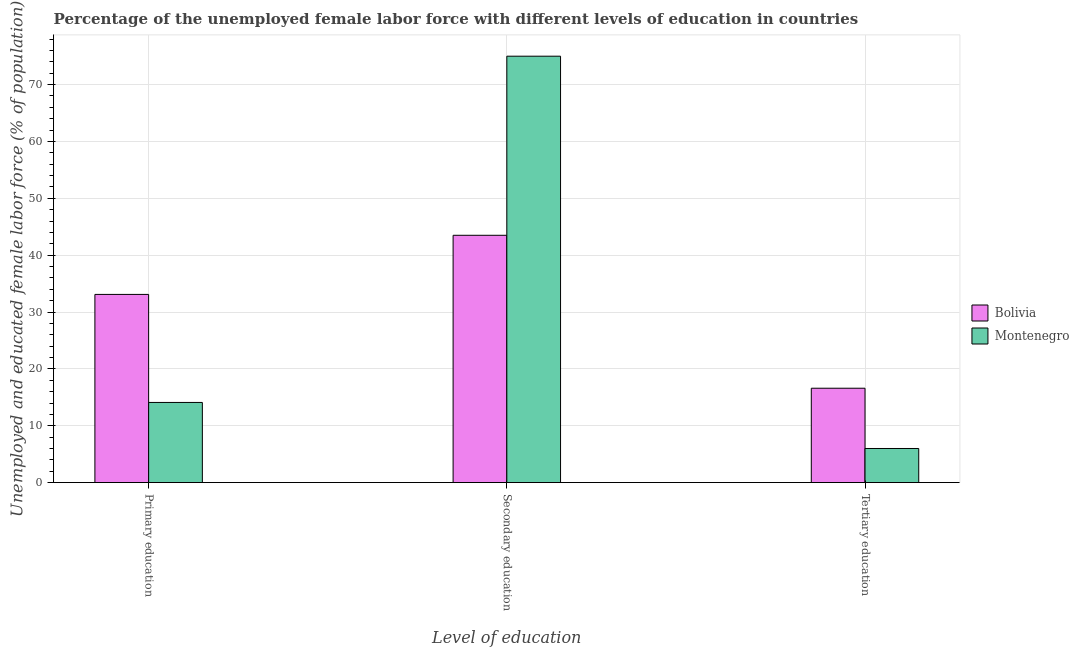How many bars are there on the 1st tick from the right?
Keep it short and to the point. 2. What is the label of the 1st group of bars from the left?
Provide a succinct answer. Primary education. What is the percentage of female labor force who received primary education in Bolivia?
Your response must be concise. 33.1. Across all countries, what is the maximum percentage of female labor force who received secondary education?
Offer a terse response. 75. Across all countries, what is the minimum percentage of female labor force who received secondary education?
Your answer should be very brief. 43.5. In which country was the percentage of female labor force who received primary education minimum?
Offer a very short reply. Montenegro. What is the total percentage of female labor force who received tertiary education in the graph?
Your answer should be compact. 22.6. What is the difference between the percentage of female labor force who received secondary education in Bolivia and that in Montenegro?
Ensure brevity in your answer.  -31.5. What is the difference between the percentage of female labor force who received secondary education in Bolivia and the percentage of female labor force who received primary education in Montenegro?
Offer a terse response. 29.4. What is the average percentage of female labor force who received primary education per country?
Provide a succinct answer. 23.6. What is the difference between the percentage of female labor force who received primary education and percentage of female labor force who received tertiary education in Montenegro?
Give a very brief answer. 8.1. What is the ratio of the percentage of female labor force who received primary education in Bolivia to that in Montenegro?
Give a very brief answer. 2.35. Is the percentage of female labor force who received primary education in Bolivia less than that in Montenegro?
Provide a short and direct response. No. Is the difference between the percentage of female labor force who received tertiary education in Bolivia and Montenegro greater than the difference between the percentage of female labor force who received secondary education in Bolivia and Montenegro?
Make the answer very short. Yes. What is the difference between the highest and the second highest percentage of female labor force who received secondary education?
Keep it short and to the point. 31.5. What is the difference between the highest and the lowest percentage of female labor force who received primary education?
Ensure brevity in your answer.  19. Is the sum of the percentage of female labor force who received tertiary education in Montenegro and Bolivia greater than the maximum percentage of female labor force who received primary education across all countries?
Your response must be concise. No. What does the 1st bar from the right in Tertiary education represents?
Make the answer very short. Montenegro. Is it the case that in every country, the sum of the percentage of female labor force who received primary education and percentage of female labor force who received secondary education is greater than the percentage of female labor force who received tertiary education?
Offer a very short reply. Yes. How many bars are there?
Ensure brevity in your answer.  6. Are all the bars in the graph horizontal?
Your response must be concise. No. How many countries are there in the graph?
Your answer should be very brief. 2. What is the difference between two consecutive major ticks on the Y-axis?
Offer a very short reply. 10. Does the graph contain any zero values?
Your answer should be very brief. No. Does the graph contain grids?
Offer a terse response. Yes. How many legend labels are there?
Your response must be concise. 2. How are the legend labels stacked?
Make the answer very short. Vertical. What is the title of the graph?
Provide a succinct answer. Percentage of the unemployed female labor force with different levels of education in countries. Does "Bulgaria" appear as one of the legend labels in the graph?
Your answer should be compact. No. What is the label or title of the X-axis?
Keep it short and to the point. Level of education. What is the label or title of the Y-axis?
Keep it short and to the point. Unemployed and educated female labor force (% of population). What is the Unemployed and educated female labor force (% of population) of Bolivia in Primary education?
Give a very brief answer. 33.1. What is the Unemployed and educated female labor force (% of population) of Montenegro in Primary education?
Your answer should be compact. 14.1. What is the Unemployed and educated female labor force (% of population) of Bolivia in Secondary education?
Provide a short and direct response. 43.5. What is the Unemployed and educated female labor force (% of population) in Montenegro in Secondary education?
Provide a short and direct response. 75. What is the Unemployed and educated female labor force (% of population) in Bolivia in Tertiary education?
Your answer should be very brief. 16.6. Across all Level of education, what is the maximum Unemployed and educated female labor force (% of population) in Bolivia?
Your answer should be very brief. 43.5. Across all Level of education, what is the maximum Unemployed and educated female labor force (% of population) in Montenegro?
Keep it short and to the point. 75. Across all Level of education, what is the minimum Unemployed and educated female labor force (% of population) in Bolivia?
Provide a succinct answer. 16.6. Across all Level of education, what is the minimum Unemployed and educated female labor force (% of population) of Montenegro?
Offer a terse response. 6. What is the total Unemployed and educated female labor force (% of population) of Bolivia in the graph?
Your answer should be very brief. 93.2. What is the total Unemployed and educated female labor force (% of population) of Montenegro in the graph?
Make the answer very short. 95.1. What is the difference between the Unemployed and educated female labor force (% of population) of Montenegro in Primary education and that in Secondary education?
Give a very brief answer. -60.9. What is the difference between the Unemployed and educated female labor force (% of population) of Bolivia in Primary education and that in Tertiary education?
Offer a terse response. 16.5. What is the difference between the Unemployed and educated female labor force (% of population) of Bolivia in Secondary education and that in Tertiary education?
Your answer should be very brief. 26.9. What is the difference between the Unemployed and educated female labor force (% of population) in Montenegro in Secondary education and that in Tertiary education?
Your answer should be compact. 69. What is the difference between the Unemployed and educated female labor force (% of population) in Bolivia in Primary education and the Unemployed and educated female labor force (% of population) in Montenegro in Secondary education?
Give a very brief answer. -41.9. What is the difference between the Unemployed and educated female labor force (% of population) in Bolivia in Primary education and the Unemployed and educated female labor force (% of population) in Montenegro in Tertiary education?
Keep it short and to the point. 27.1. What is the difference between the Unemployed and educated female labor force (% of population) in Bolivia in Secondary education and the Unemployed and educated female labor force (% of population) in Montenegro in Tertiary education?
Keep it short and to the point. 37.5. What is the average Unemployed and educated female labor force (% of population) of Bolivia per Level of education?
Keep it short and to the point. 31.07. What is the average Unemployed and educated female labor force (% of population) of Montenegro per Level of education?
Offer a terse response. 31.7. What is the difference between the Unemployed and educated female labor force (% of population) in Bolivia and Unemployed and educated female labor force (% of population) in Montenegro in Secondary education?
Keep it short and to the point. -31.5. What is the difference between the Unemployed and educated female labor force (% of population) in Bolivia and Unemployed and educated female labor force (% of population) in Montenegro in Tertiary education?
Offer a very short reply. 10.6. What is the ratio of the Unemployed and educated female labor force (% of population) in Bolivia in Primary education to that in Secondary education?
Offer a terse response. 0.76. What is the ratio of the Unemployed and educated female labor force (% of population) in Montenegro in Primary education to that in Secondary education?
Your response must be concise. 0.19. What is the ratio of the Unemployed and educated female labor force (% of population) in Bolivia in Primary education to that in Tertiary education?
Ensure brevity in your answer.  1.99. What is the ratio of the Unemployed and educated female labor force (% of population) of Montenegro in Primary education to that in Tertiary education?
Give a very brief answer. 2.35. What is the ratio of the Unemployed and educated female labor force (% of population) of Bolivia in Secondary education to that in Tertiary education?
Provide a short and direct response. 2.62. What is the difference between the highest and the second highest Unemployed and educated female labor force (% of population) in Bolivia?
Provide a short and direct response. 10.4. What is the difference between the highest and the second highest Unemployed and educated female labor force (% of population) in Montenegro?
Provide a short and direct response. 60.9. What is the difference between the highest and the lowest Unemployed and educated female labor force (% of population) in Bolivia?
Offer a very short reply. 26.9. What is the difference between the highest and the lowest Unemployed and educated female labor force (% of population) of Montenegro?
Your response must be concise. 69. 